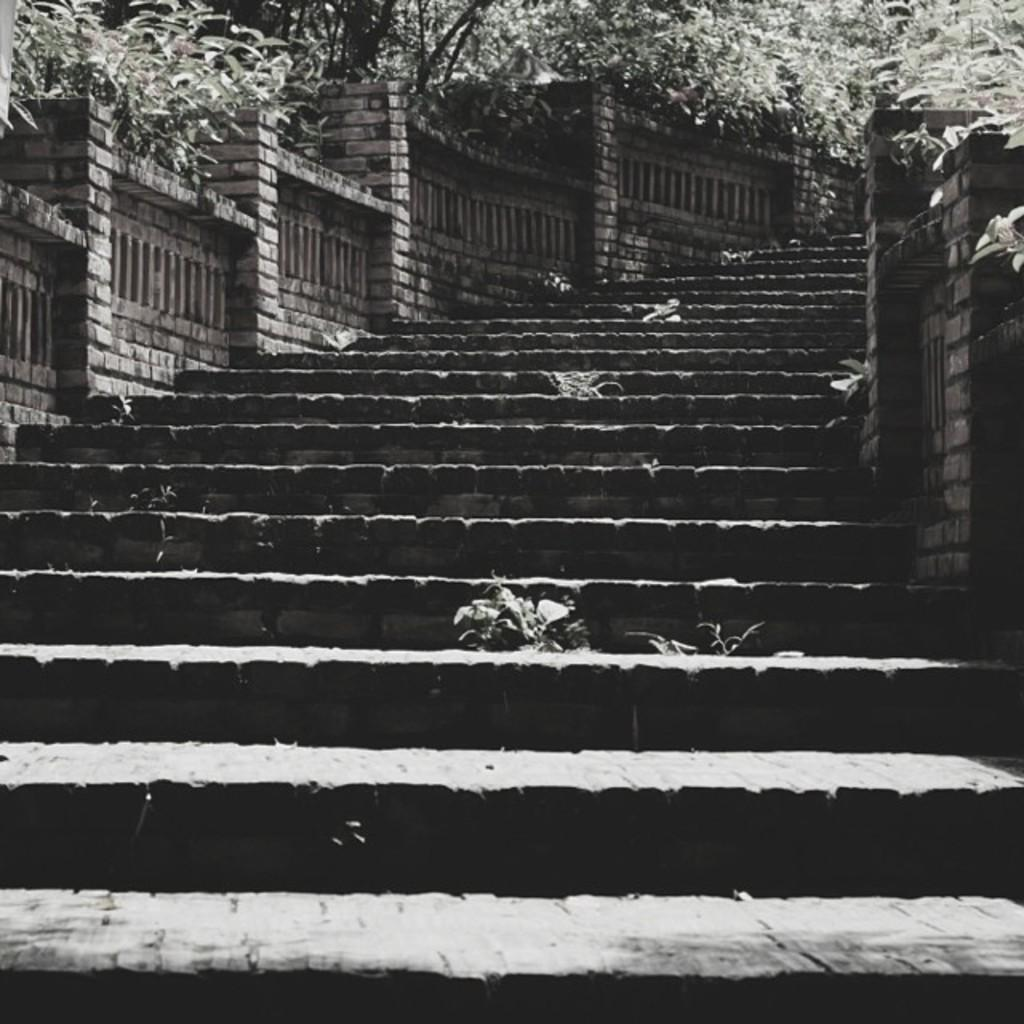What architectural feature is present in the image? There are steps in the image. What is in front of the steps in the image? There are walls in front in the image. What can be seen in the background of the image? There are trees and plants in the background of the image. What type of snake can be seen slithering through the waves in the image? There is no snake or waves present in the image; it features steps, walls, trees, and plants. 